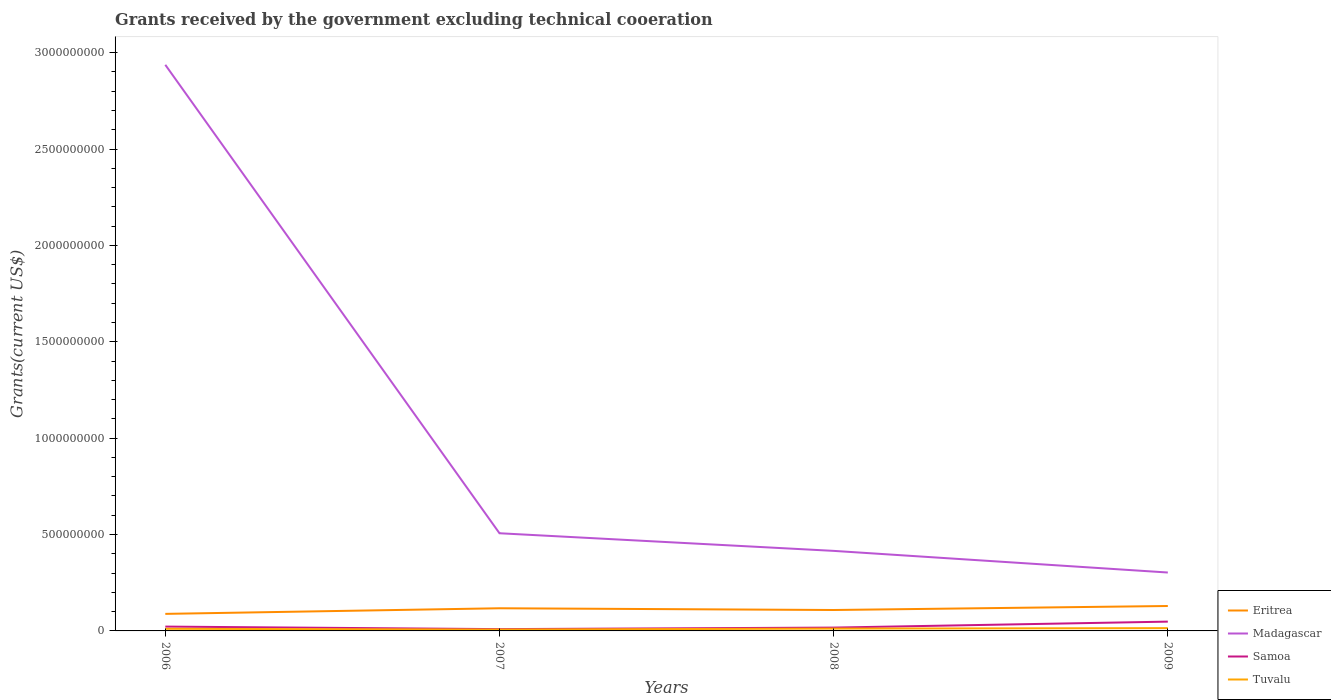How many different coloured lines are there?
Provide a succinct answer. 4. Is the number of lines equal to the number of legend labels?
Offer a very short reply. Yes. Across all years, what is the maximum total grants received by the government in Samoa?
Your answer should be compact. 9.34e+06. What is the total total grants received by the government in Samoa in the graph?
Your response must be concise. 5.24e+06. What is the difference between the highest and the second highest total grants received by the government in Eritrea?
Your response must be concise. 4.08e+07. What is the difference between the highest and the lowest total grants received by the government in Tuvalu?
Ensure brevity in your answer.  2. Is the total grants received by the government in Madagascar strictly greater than the total grants received by the government in Tuvalu over the years?
Provide a short and direct response. No. How many years are there in the graph?
Provide a short and direct response. 4. Does the graph contain any zero values?
Give a very brief answer. No. Does the graph contain grids?
Ensure brevity in your answer.  No. Where does the legend appear in the graph?
Provide a short and direct response. Bottom right. How are the legend labels stacked?
Your answer should be very brief. Vertical. What is the title of the graph?
Your response must be concise. Grants received by the government excluding technical cooeration. What is the label or title of the X-axis?
Provide a short and direct response. Years. What is the label or title of the Y-axis?
Your response must be concise. Grants(current US$). What is the Grants(current US$) of Eritrea in 2006?
Offer a terse response. 8.85e+07. What is the Grants(current US$) of Madagascar in 2006?
Provide a succinct answer. 2.94e+09. What is the Grants(current US$) of Samoa in 2006?
Offer a very short reply. 2.25e+07. What is the Grants(current US$) in Tuvalu in 2006?
Your response must be concise. 1.11e+07. What is the Grants(current US$) of Eritrea in 2007?
Provide a short and direct response. 1.18e+08. What is the Grants(current US$) of Madagascar in 2007?
Provide a succinct answer. 5.07e+08. What is the Grants(current US$) in Samoa in 2007?
Give a very brief answer. 9.34e+06. What is the Grants(current US$) in Tuvalu in 2007?
Your answer should be compact. 7.21e+06. What is the Grants(current US$) of Eritrea in 2008?
Offer a very short reply. 1.09e+08. What is the Grants(current US$) of Madagascar in 2008?
Ensure brevity in your answer.  4.15e+08. What is the Grants(current US$) of Samoa in 2008?
Your response must be concise. 1.72e+07. What is the Grants(current US$) in Tuvalu in 2008?
Ensure brevity in your answer.  1.20e+07. What is the Grants(current US$) of Eritrea in 2009?
Offer a terse response. 1.29e+08. What is the Grants(current US$) of Madagascar in 2009?
Your answer should be very brief. 3.03e+08. What is the Grants(current US$) in Samoa in 2009?
Provide a succinct answer. 4.82e+07. What is the Grants(current US$) of Tuvalu in 2009?
Your answer should be very brief. 1.44e+07. Across all years, what is the maximum Grants(current US$) of Eritrea?
Offer a terse response. 1.29e+08. Across all years, what is the maximum Grants(current US$) in Madagascar?
Provide a short and direct response. 2.94e+09. Across all years, what is the maximum Grants(current US$) in Samoa?
Make the answer very short. 4.82e+07. Across all years, what is the maximum Grants(current US$) of Tuvalu?
Provide a short and direct response. 1.44e+07. Across all years, what is the minimum Grants(current US$) of Eritrea?
Provide a short and direct response. 8.85e+07. Across all years, what is the minimum Grants(current US$) of Madagascar?
Offer a terse response. 3.03e+08. Across all years, what is the minimum Grants(current US$) in Samoa?
Ensure brevity in your answer.  9.34e+06. Across all years, what is the minimum Grants(current US$) of Tuvalu?
Make the answer very short. 7.21e+06. What is the total Grants(current US$) of Eritrea in the graph?
Your answer should be very brief. 4.44e+08. What is the total Grants(current US$) of Madagascar in the graph?
Offer a terse response. 4.16e+09. What is the total Grants(current US$) in Samoa in the graph?
Your answer should be very brief. 9.73e+07. What is the total Grants(current US$) of Tuvalu in the graph?
Provide a succinct answer. 4.47e+07. What is the difference between the Grants(current US$) in Eritrea in 2006 and that in 2007?
Ensure brevity in your answer.  -2.91e+07. What is the difference between the Grants(current US$) of Madagascar in 2006 and that in 2007?
Your answer should be very brief. 2.43e+09. What is the difference between the Grants(current US$) of Samoa in 2006 and that in 2007?
Provide a succinct answer. 1.32e+07. What is the difference between the Grants(current US$) in Tuvalu in 2006 and that in 2007?
Your response must be concise. 3.85e+06. What is the difference between the Grants(current US$) in Eritrea in 2006 and that in 2008?
Ensure brevity in your answer.  -2.01e+07. What is the difference between the Grants(current US$) of Madagascar in 2006 and that in 2008?
Ensure brevity in your answer.  2.52e+09. What is the difference between the Grants(current US$) of Samoa in 2006 and that in 2008?
Your answer should be compact. 5.24e+06. What is the difference between the Grants(current US$) in Tuvalu in 2006 and that in 2008?
Offer a terse response. -9.70e+05. What is the difference between the Grants(current US$) in Eritrea in 2006 and that in 2009?
Offer a very short reply. -4.08e+07. What is the difference between the Grants(current US$) of Madagascar in 2006 and that in 2009?
Keep it short and to the point. 2.63e+09. What is the difference between the Grants(current US$) in Samoa in 2006 and that in 2009?
Provide a short and direct response. -2.57e+07. What is the difference between the Grants(current US$) in Tuvalu in 2006 and that in 2009?
Offer a terse response. -3.33e+06. What is the difference between the Grants(current US$) of Eritrea in 2007 and that in 2008?
Keep it short and to the point. 8.96e+06. What is the difference between the Grants(current US$) of Madagascar in 2007 and that in 2008?
Your answer should be very brief. 9.14e+07. What is the difference between the Grants(current US$) of Samoa in 2007 and that in 2008?
Keep it short and to the point. -7.91e+06. What is the difference between the Grants(current US$) of Tuvalu in 2007 and that in 2008?
Make the answer very short. -4.82e+06. What is the difference between the Grants(current US$) of Eritrea in 2007 and that in 2009?
Provide a short and direct response. -1.18e+07. What is the difference between the Grants(current US$) of Madagascar in 2007 and that in 2009?
Provide a short and direct response. 2.04e+08. What is the difference between the Grants(current US$) of Samoa in 2007 and that in 2009?
Offer a very short reply. -3.88e+07. What is the difference between the Grants(current US$) of Tuvalu in 2007 and that in 2009?
Your answer should be very brief. -7.18e+06. What is the difference between the Grants(current US$) of Eritrea in 2008 and that in 2009?
Your answer should be very brief. -2.07e+07. What is the difference between the Grants(current US$) of Madagascar in 2008 and that in 2009?
Your answer should be very brief. 1.12e+08. What is the difference between the Grants(current US$) of Samoa in 2008 and that in 2009?
Your response must be concise. -3.09e+07. What is the difference between the Grants(current US$) in Tuvalu in 2008 and that in 2009?
Ensure brevity in your answer.  -2.36e+06. What is the difference between the Grants(current US$) in Eritrea in 2006 and the Grants(current US$) in Madagascar in 2007?
Provide a succinct answer. -4.18e+08. What is the difference between the Grants(current US$) of Eritrea in 2006 and the Grants(current US$) of Samoa in 2007?
Give a very brief answer. 7.91e+07. What is the difference between the Grants(current US$) in Eritrea in 2006 and the Grants(current US$) in Tuvalu in 2007?
Your response must be concise. 8.12e+07. What is the difference between the Grants(current US$) of Madagascar in 2006 and the Grants(current US$) of Samoa in 2007?
Provide a succinct answer. 2.93e+09. What is the difference between the Grants(current US$) in Madagascar in 2006 and the Grants(current US$) in Tuvalu in 2007?
Your answer should be compact. 2.93e+09. What is the difference between the Grants(current US$) of Samoa in 2006 and the Grants(current US$) of Tuvalu in 2007?
Offer a terse response. 1.53e+07. What is the difference between the Grants(current US$) in Eritrea in 2006 and the Grants(current US$) in Madagascar in 2008?
Your answer should be very brief. -3.27e+08. What is the difference between the Grants(current US$) in Eritrea in 2006 and the Grants(current US$) in Samoa in 2008?
Offer a terse response. 7.12e+07. What is the difference between the Grants(current US$) in Eritrea in 2006 and the Grants(current US$) in Tuvalu in 2008?
Your response must be concise. 7.64e+07. What is the difference between the Grants(current US$) in Madagascar in 2006 and the Grants(current US$) in Samoa in 2008?
Make the answer very short. 2.92e+09. What is the difference between the Grants(current US$) in Madagascar in 2006 and the Grants(current US$) in Tuvalu in 2008?
Provide a succinct answer. 2.92e+09. What is the difference between the Grants(current US$) in Samoa in 2006 and the Grants(current US$) in Tuvalu in 2008?
Your response must be concise. 1.05e+07. What is the difference between the Grants(current US$) in Eritrea in 2006 and the Grants(current US$) in Madagascar in 2009?
Ensure brevity in your answer.  -2.15e+08. What is the difference between the Grants(current US$) in Eritrea in 2006 and the Grants(current US$) in Samoa in 2009?
Keep it short and to the point. 4.03e+07. What is the difference between the Grants(current US$) of Eritrea in 2006 and the Grants(current US$) of Tuvalu in 2009?
Keep it short and to the point. 7.41e+07. What is the difference between the Grants(current US$) of Madagascar in 2006 and the Grants(current US$) of Samoa in 2009?
Give a very brief answer. 2.89e+09. What is the difference between the Grants(current US$) in Madagascar in 2006 and the Grants(current US$) in Tuvalu in 2009?
Offer a very short reply. 2.92e+09. What is the difference between the Grants(current US$) of Samoa in 2006 and the Grants(current US$) of Tuvalu in 2009?
Provide a short and direct response. 8.10e+06. What is the difference between the Grants(current US$) of Eritrea in 2007 and the Grants(current US$) of Madagascar in 2008?
Provide a short and direct response. -2.98e+08. What is the difference between the Grants(current US$) in Eritrea in 2007 and the Grants(current US$) in Samoa in 2008?
Keep it short and to the point. 1.00e+08. What is the difference between the Grants(current US$) in Eritrea in 2007 and the Grants(current US$) in Tuvalu in 2008?
Offer a terse response. 1.06e+08. What is the difference between the Grants(current US$) of Madagascar in 2007 and the Grants(current US$) of Samoa in 2008?
Your response must be concise. 4.89e+08. What is the difference between the Grants(current US$) in Madagascar in 2007 and the Grants(current US$) in Tuvalu in 2008?
Your response must be concise. 4.95e+08. What is the difference between the Grants(current US$) of Samoa in 2007 and the Grants(current US$) of Tuvalu in 2008?
Provide a short and direct response. -2.69e+06. What is the difference between the Grants(current US$) of Eritrea in 2007 and the Grants(current US$) of Madagascar in 2009?
Keep it short and to the point. -1.85e+08. What is the difference between the Grants(current US$) of Eritrea in 2007 and the Grants(current US$) of Samoa in 2009?
Your response must be concise. 6.93e+07. What is the difference between the Grants(current US$) of Eritrea in 2007 and the Grants(current US$) of Tuvalu in 2009?
Your answer should be compact. 1.03e+08. What is the difference between the Grants(current US$) of Madagascar in 2007 and the Grants(current US$) of Samoa in 2009?
Keep it short and to the point. 4.59e+08. What is the difference between the Grants(current US$) in Madagascar in 2007 and the Grants(current US$) in Tuvalu in 2009?
Your response must be concise. 4.92e+08. What is the difference between the Grants(current US$) in Samoa in 2007 and the Grants(current US$) in Tuvalu in 2009?
Offer a very short reply. -5.05e+06. What is the difference between the Grants(current US$) of Eritrea in 2008 and the Grants(current US$) of Madagascar in 2009?
Provide a short and direct response. -1.94e+08. What is the difference between the Grants(current US$) in Eritrea in 2008 and the Grants(current US$) in Samoa in 2009?
Offer a very short reply. 6.04e+07. What is the difference between the Grants(current US$) in Eritrea in 2008 and the Grants(current US$) in Tuvalu in 2009?
Your answer should be very brief. 9.42e+07. What is the difference between the Grants(current US$) of Madagascar in 2008 and the Grants(current US$) of Samoa in 2009?
Offer a terse response. 3.67e+08. What is the difference between the Grants(current US$) of Madagascar in 2008 and the Grants(current US$) of Tuvalu in 2009?
Give a very brief answer. 4.01e+08. What is the difference between the Grants(current US$) in Samoa in 2008 and the Grants(current US$) in Tuvalu in 2009?
Offer a terse response. 2.86e+06. What is the average Grants(current US$) of Eritrea per year?
Provide a short and direct response. 1.11e+08. What is the average Grants(current US$) of Madagascar per year?
Keep it short and to the point. 1.04e+09. What is the average Grants(current US$) in Samoa per year?
Provide a short and direct response. 2.43e+07. What is the average Grants(current US$) in Tuvalu per year?
Provide a short and direct response. 1.12e+07. In the year 2006, what is the difference between the Grants(current US$) in Eritrea and Grants(current US$) in Madagascar?
Provide a short and direct response. -2.85e+09. In the year 2006, what is the difference between the Grants(current US$) in Eritrea and Grants(current US$) in Samoa?
Give a very brief answer. 6.60e+07. In the year 2006, what is the difference between the Grants(current US$) of Eritrea and Grants(current US$) of Tuvalu?
Make the answer very short. 7.74e+07. In the year 2006, what is the difference between the Grants(current US$) of Madagascar and Grants(current US$) of Samoa?
Give a very brief answer. 2.91e+09. In the year 2006, what is the difference between the Grants(current US$) of Madagascar and Grants(current US$) of Tuvalu?
Keep it short and to the point. 2.93e+09. In the year 2006, what is the difference between the Grants(current US$) of Samoa and Grants(current US$) of Tuvalu?
Make the answer very short. 1.14e+07. In the year 2007, what is the difference between the Grants(current US$) of Eritrea and Grants(current US$) of Madagascar?
Your answer should be compact. -3.89e+08. In the year 2007, what is the difference between the Grants(current US$) of Eritrea and Grants(current US$) of Samoa?
Provide a succinct answer. 1.08e+08. In the year 2007, what is the difference between the Grants(current US$) in Eritrea and Grants(current US$) in Tuvalu?
Offer a very short reply. 1.10e+08. In the year 2007, what is the difference between the Grants(current US$) of Madagascar and Grants(current US$) of Samoa?
Offer a terse response. 4.97e+08. In the year 2007, what is the difference between the Grants(current US$) in Madagascar and Grants(current US$) in Tuvalu?
Your response must be concise. 5.00e+08. In the year 2007, what is the difference between the Grants(current US$) of Samoa and Grants(current US$) of Tuvalu?
Provide a succinct answer. 2.13e+06. In the year 2008, what is the difference between the Grants(current US$) in Eritrea and Grants(current US$) in Madagascar?
Keep it short and to the point. -3.07e+08. In the year 2008, what is the difference between the Grants(current US$) in Eritrea and Grants(current US$) in Samoa?
Keep it short and to the point. 9.13e+07. In the year 2008, what is the difference between the Grants(current US$) of Eritrea and Grants(current US$) of Tuvalu?
Your answer should be very brief. 9.65e+07. In the year 2008, what is the difference between the Grants(current US$) in Madagascar and Grants(current US$) in Samoa?
Your answer should be very brief. 3.98e+08. In the year 2008, what is the difference between the Grants(current US$) in Madagascar and Grants(current US$) in Tuvalu?
Ensure brevity in your answer.  4.03e+08. In the year 2008, what is the difference between the Grants(current US$) in Samoa and Grants(current US$) in Tuvalu?
Offer a very short reply. 5.22e+06. In the year 2009, what is the difference between the Grants(current US$) in Eritrea and Grants(current US$) in Madagascar?
Make the answer very short. -1.74e+08. In the year 2009, what is the difference between the Grants(current US$) in Eritrea and Grants(current US$) in Samoa?
Make the answer very short. 8.11e+07. In the year 2009, what is the difference between the Grants(current US$) in Eritrea and Grants(current US$) in Tuvalu?
Provide a succinct answer. 1.15e+08. In the year 2009, what is the difference between the Grants(current US$) of Madagascar and Grants(current US$) of Samoa?
Provide a short and direct response. 2.55e+08. In the year 2009, what is the difference between the Grants(current US$) of Madagascar and Grants(current US$) of Tuvalu?
Ensure brevity in your answer.  2.89e+08. In the year 2009, what is the difference between the Grants(current US$) of Samoa and Grants(current US$) of Tuvalu?
Provide a short and direct response. 3.38e+07. What is the ratio of the Grants(current US$) in Eritrea in 2006 to that in 2007?
Your answer should be compact. 0.75. What is the ratio of the Grants(current US$) of Madagascar in 2006 to that in 2007?
Provide a short and direct response. 5.8. What is the ratio of the Grants(current US$) in Samoa in 2006 to that in 2007?
Offer a terse response. 2.41. What is the ratio of the Grants(current US$) of Tuvalu in 2006 to that in 2007?
Your answer should be very brief. 1.53. What is the ratio of the Grants(current US$) of Eritrea in 2006 to that in 2008?
Provide a short and direct response. 0.81. What is the ratio of the Grants(current US$) in Madagascar in 2006 to that in 2008?
Keep it short and to the point. 7.07. What is the ratio of the Grants(current US$) of Samoa in 2006 to that in 2008?
Your answer should be very brief. 1.3. What is the ratio of the Grants(current US$) in Tuvalu in 2006 to that in 2008?
Offer a terse response. 0.92. What is the ratio of the Grants(current US$) in Eritrea in 2006 to that in 2009?
Make the answer very short. 0.68. What is the ratio of the Grants(current US$) of Madagascar in 2006 to that in 2009?
Offer a very short reply. 9.69. What is the ratio of the Grants(current US$) in Samoa in 2006 to that in 2009?
Your answer should be very brief. 0.47. What is the ratio of the Grants(current US$) of Tuvalu in 2006 to that in 2009?
Your response must be concise. 0.77. What is the ratio of the Grants(current US$) in Eritrea in 2007 to that in 2008?
Give a very brief answer. 1.08. What is the ratio of the Grants(current US$) of Madagascar in 2007 to that in 2008?
Your response must be concise. 1.22. What is the ratio of the Grants(current US$) in Samoa in 2007 to that in 2008?
Make the answer very short. 0.54. What is the ratio of the Grants(current US$) in Tuvalu in 2007 to that in 2008?
Keep it short and to the point. 0.6. What is the ratio of the Grants(current US$) of Eritrea in 2007 to that in 2009?
Offer a very short reply. 0.91. What is the ratio of the Grants(current US$) in Madagascar in 2007 to that in 2009?
Your answer should be compact. 1.67. What is the ratio of the Grants(current US$) of Samoa in 2007 to that in 2009?
Provide a short and direct response. 0.19. What is the ratio of the Grants(current US$) of Tuvalu in 2007 to that in 2009?
Ensure brevity in your answer.  0.5. What is the ratio of the Grants(current US$) of Eritrea in 2008 to that in 2009?
Give a very brief answer. 0.84. What is the ratio of the Grants(current US$) of Madagascar in 2008 to that in 2009?
Keep it short and to the point. 1.37. What is the ratio of the Grants(current US$) of Samoa in 2008 to that in 2009?
Your response must be concise. 0.36. What is the ratio of the Grants(current US$) in Tuvalu in 2008 to that in 2009?
Make the answer very short. 0.84. What is the difference between the highest and the second highest Grants(current US$) in Eritrea?
Your answer should be compact. 1.18e+07. What is the difference between the highest and the second highest Grants(current US$) in Madagascar?
Ensure brevity in your answer.  2.43e+09. What is the difference between the highest and the second highest Grants(current US$) of Samoa?
Your answer should be compact. 2.57e+07. What is the difference between the highest and the second highest Grants(current US$) of Tuvalu?
Ensure brevity in your answer.  2.36e+06. What is the difference between the highest and the lowest Grants(current US$) in Eritrea?
Make the answer very short. 4.08e+07. What is the difference between the highest and the lowest Grants(current US$) of Madagascar?
Provide a succinct answer. 2.63e+09. What is the difference between the highest and the lowest Grants(current US$) of Samoa?
Your response must be concise. 3.88e+07. What is the difference between the highest and the lowest Grants(current US$) in Tuvalu?
Keep it short and to the point. 7.18e+06. 